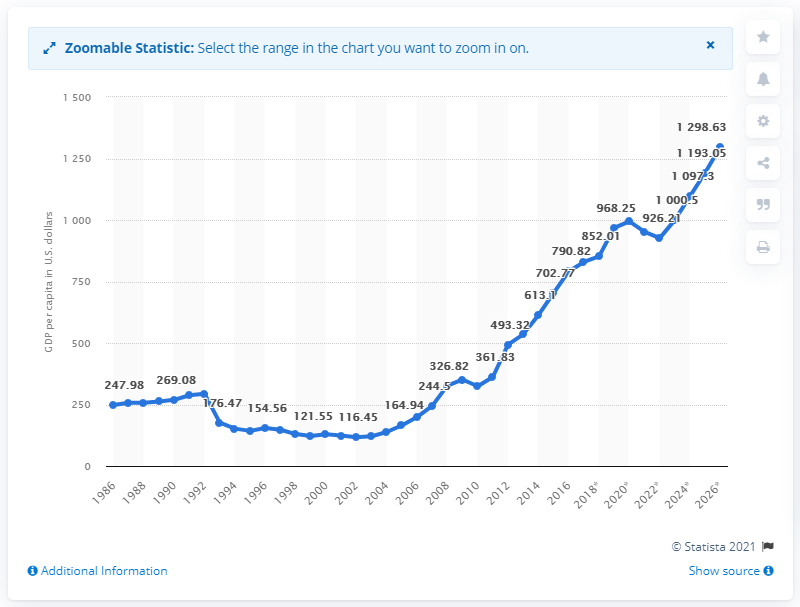List a handful of essential elements in this visual. In 2016, the GDP per capita in Ethiopia was 790.82. 